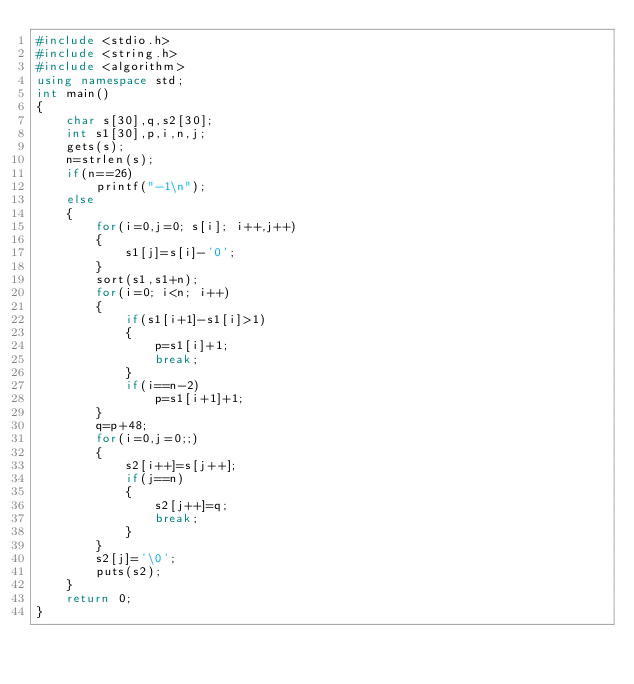Convert code to text. <code><loc_0><loc_0><loc_500><loc_500><_C++_>#include <stdio.h>
#include <string.h>
#include <algorithm>
using namespace std;
int main()
{
    char s[30],q,s2[30];
    int s1[30],p,i,n,j;
    gets(s);
    n=strlen(s);
    if(n==26)
        printf("-1\n");
    else
    {
        for(i=0,j=0; s[i]; i++,j++)
        {
            s1[j]=s[i]-'0';
        }
        sort(s1,s1+n);
        for(i=0; i<n; i++)
        {
            if(s1[i+1]-s1[i]>1)
            {
                p=s1[i]+1;
                break;
            }
            if(i==n-2)
                p=s1[i+1]+1;
        }
        q=p+48;
        for(i=0,j=0;;)
        {
            s2[i++]=s[j++];
            if(j==n)
            {
                s2[j++]=q;
                break;
            }
        }
        s2[j]='\0';
        puts(s2);
    }
    return 0;
}
</code> 